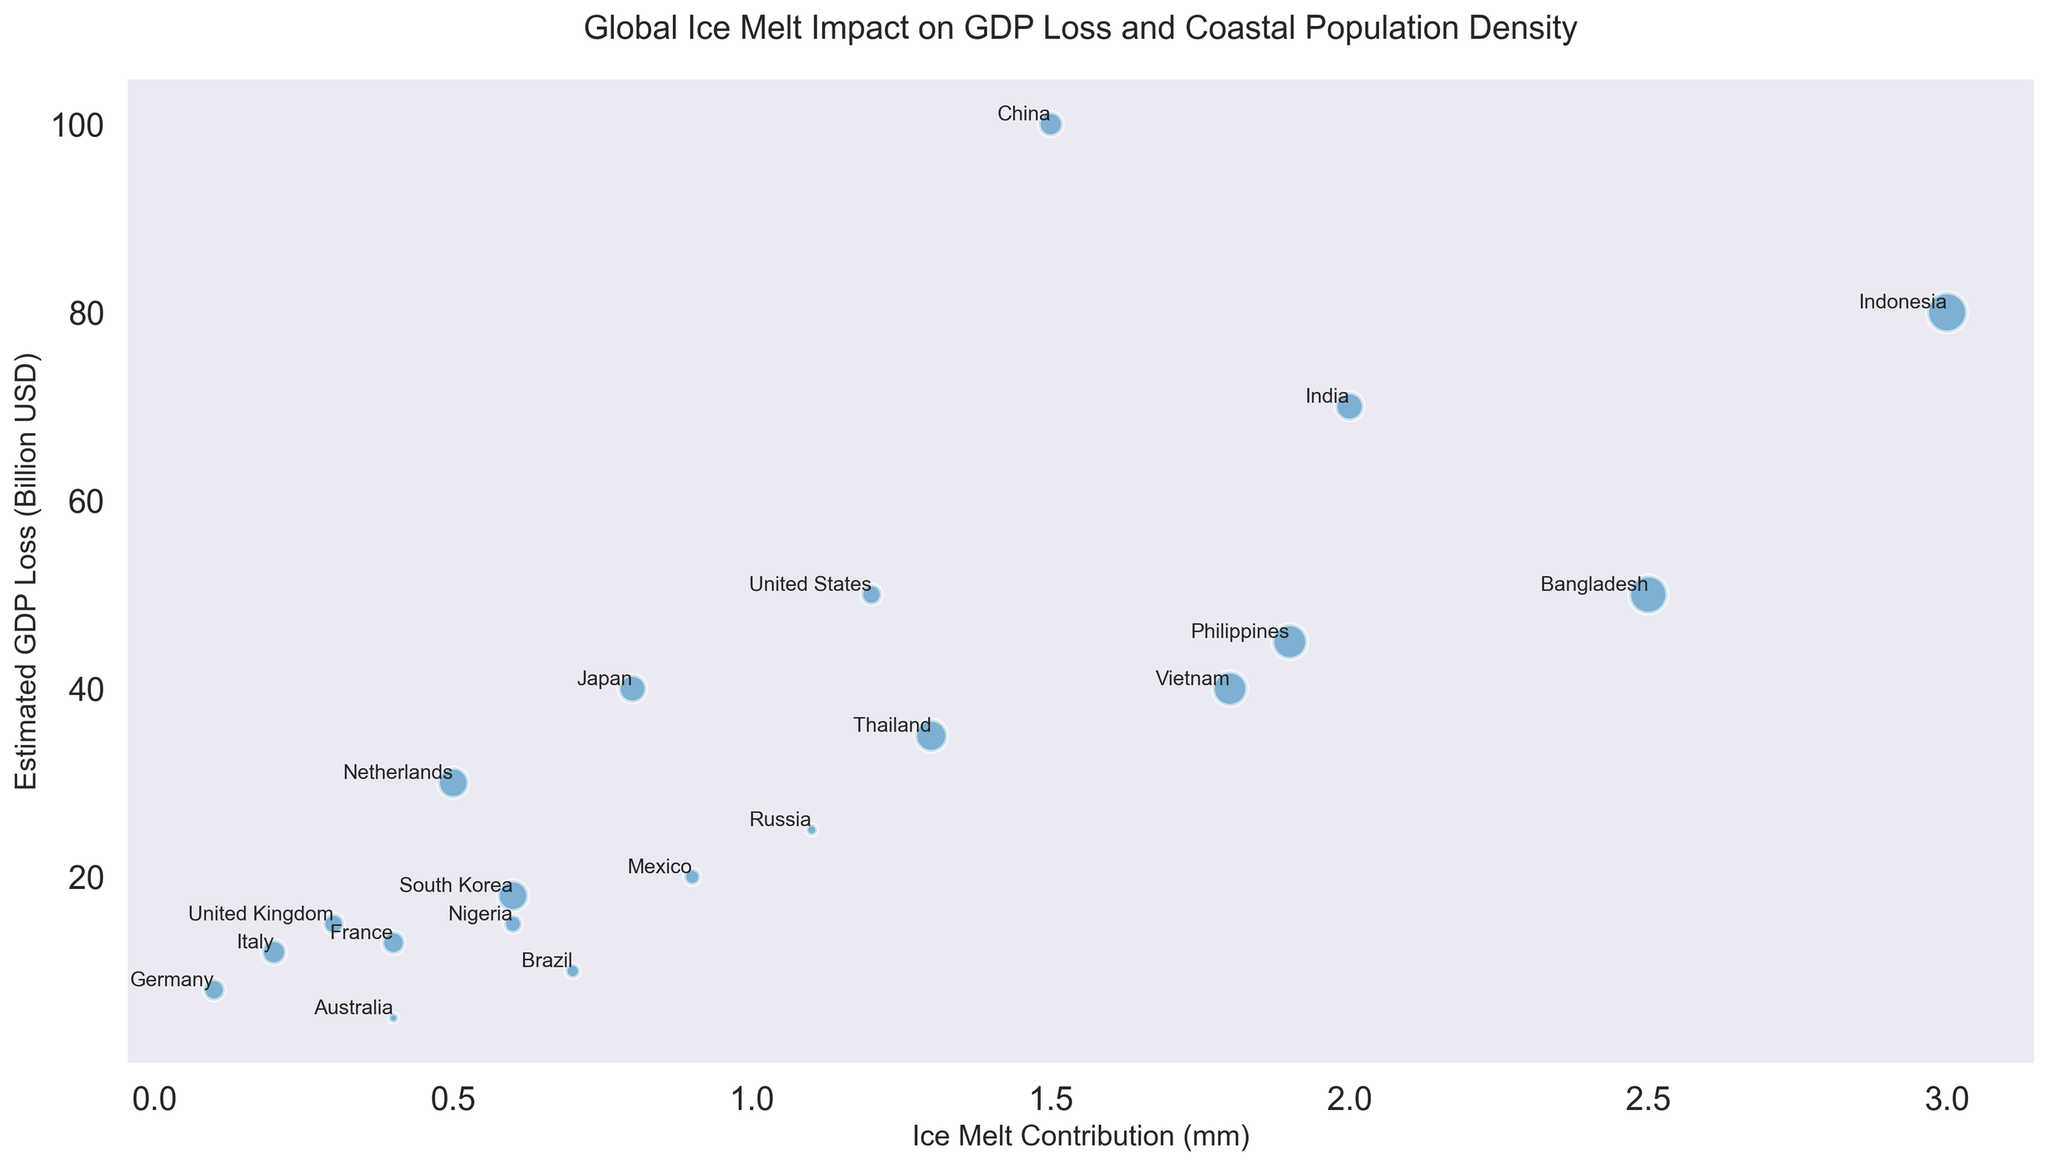Which country has the largest bubble size? The bubble size represents coastal population density. By comparing the sizes visually, Indonesia has the largest bubble, indicating the highest coastal population density.
Answer: Indonesia Which country experiences the highest estimated GDP loss? By looking at the y-axis representing GDP loss, China has the highest value, with an estimated loss of 100 billion USD.
Answer: China What is the total ice melt contribution of Bangladesh and Indonesia? Adding the ice melt contributions of Bangladesh (2.5 mm) and Indonesia (3.0 mm), we get 2.5 + 3.0 = 5.5 mm.
Answer: 5.5 mm Which two countries have the smallest ice melt contributions? Comparing the positions on the x-axis for the smallest values, Germany and Italy have the smallest ice melt contributions of 0.1 mm and 0.2 mm, respectively.
Answer: Germany and Italy Is the coastal population density of Japan higher or lower than that of the Netherlands? By comparing the bubble sizes of Japan and the Netherlands, Japan's bubble is smaller, indicating a lower coastal population density than the Netherlands.
Answer: Lower Which country has a bubble size similar to the United States but a higher GDP loss? Looking for a bubble size comparable to the United States (100 in coastal population density) and higher GDP loss on the y-axis, China (200 in population density, 100 billion USD in GDP loss) matches this criterion.
Answer: China What is the sum of the estimated GDP losses for the countries with the three highest ice melt contributions? Identifying the three countries: Indonesia (3.0 mm, 80 billion USD), Bangladesh (2.5 mm, 50 billion USD), and India (2.0 mm, 70 billion USD); their total GDP loss is 80 + 50 + 70 = 200 billion USD.
Answer: 200 billion USD Which country with an ice melt contribution less than 1 mm has the highest coastal population density? Filtering for countries with ice melt contributions less than 1 mm, the Netherlands (with 500 in population density) has the highest coastal population density in this range.
Answer: Netherlands 